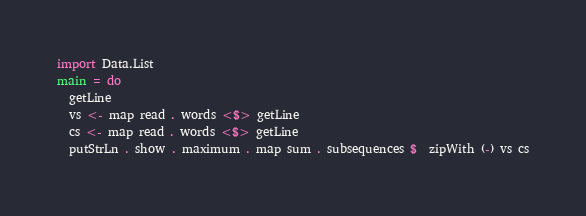<code> <loc_0><loc_0><loc_500><loc_500><_Haskell_>import Data.List
main = do
  getLine
  vs <- map read . words <$> getLine
  cs <- map read . words <$> getLine
  putStrLn . show . maximum . map sum . subsequences $  zipWith (-) vs cs
</code> 